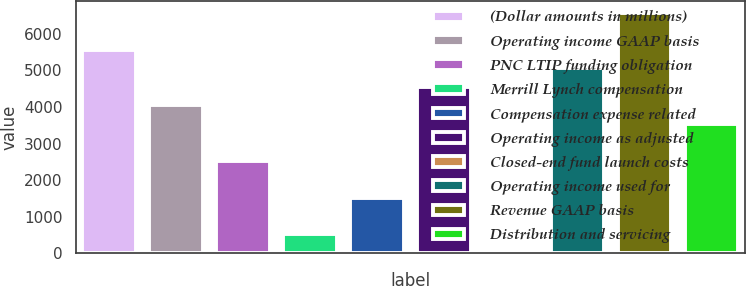Convert chart. <chart><loc_0><loc_0><loc_500><loc_500><bar_chart><fcel>(Dollar amounts in millions)<fcel>Operating income GAAP basis<fcel>PNC LTIP funding obligation<fcel>Merrill Lynch compensation<fcel>Compensation expense related<fcel>Operating income as adjusted<fcel>Closed-end fund launch costs<fcel>Operating income used for<fcel>Revenue GAAP basis<fcel>Distribution and servicing<nl><fcel>5569.5<fcel>4053<fcel>2536.5<fcel>514.5<fcel>1525.5<fcel>4558.5<fcel>9<fcel>5064<fcel>6580.5<fcel>3547.5<nl></chart> 